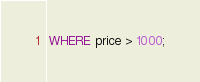<code> <loc_0><loc_0><loc_500><loc_500><_SQL_>WHERE price > 1000;
</code> 